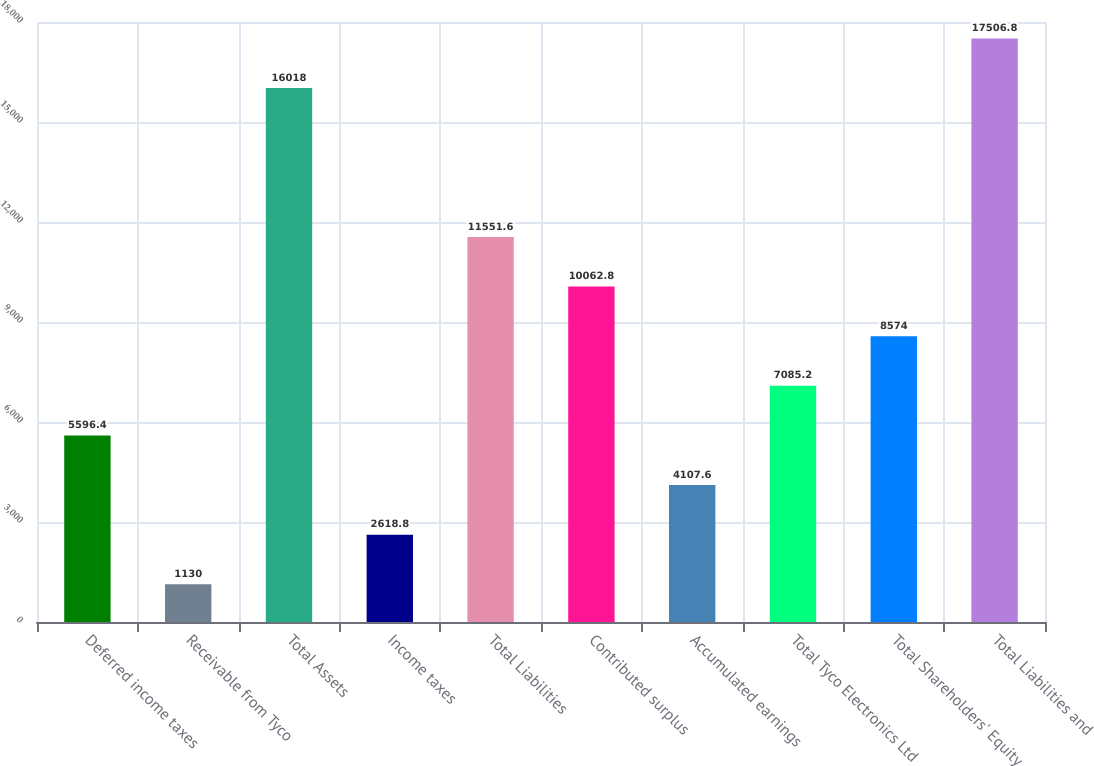Convert chart. <chart><loc_0><loc_0><loc_500><loc_500><bar_chart><fcel>Deferred income taxes<fcel>Receivable from Tyco<fcel>Total Assets<fcel>Income taxes<fcel>Total Liabilities<fcel>Contributed surplus<fcel>Accumulated earnings<fcel>Total Tyco Electronics Ltd<fcel>Total Shareholders' Equity<fcel>Total Liabilities and<nl><fcel>5596.4<fcel>1130<fcel>16018<fcel>2618.8<fcel>11551.6<fcel>10062.8<fcel>4107.6<fcel>7085.2<fcel>8574<fcel>17506.8<nl></chart> 